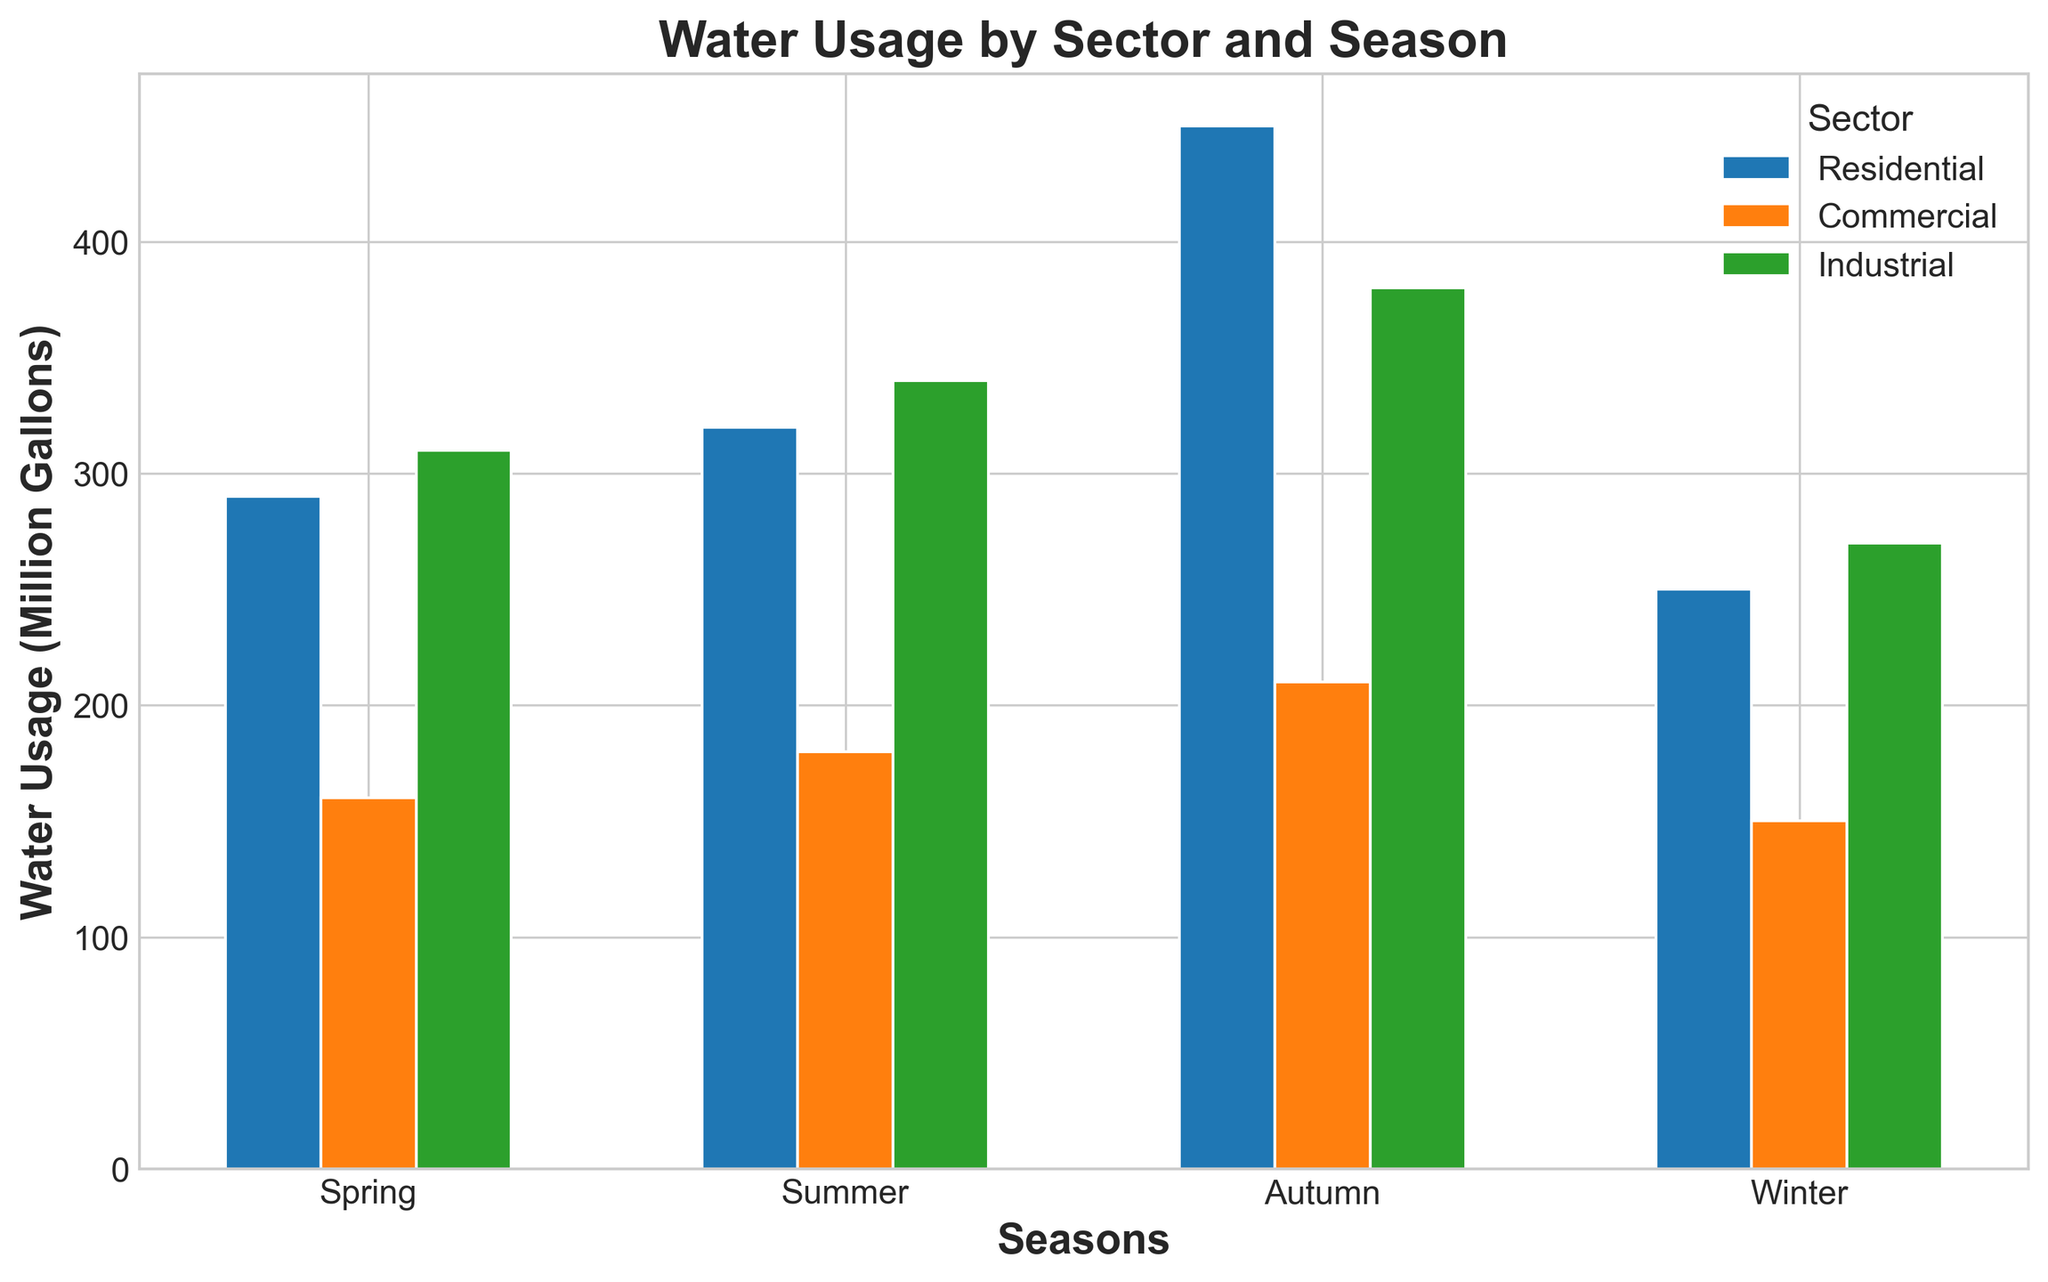What is the season with the lowest water usage for the residential sector? By examining the residential sector's bars across all seasons, the shortest bar represents the lowest water usage. The winter season has the shortest bar.
Answer: Winter Which sector has the highest water usage in summer? Compare the height of all bars in the summer group. The residential sector bar is the tallest in this group.
Answer: Residential Compare the water usage between the residential and industrial sectors in spring. Which one is higher? Compare the heights of the bars for the residential and industrial sectors in the spring. The industrial sector's bar is taller than the residential sector's bar.
Answer: Industrial What is the total water usage for the commercial sector across all seasons? Sum the height of the bars for the commercial sector in spring, summer, autumn, and winter: 180 + 210 + 160 + 150 = 700.
Answer: 700 Million Gallons Which season has the smallest overall water usage considering all three sectors combined? Sum the height of the bars for all sectors in each season:  
Spring: 320 + 180 + 340 = 840  
Summer: 450 + 210 + 380 = 1040  
Autumn: 290 + 160 + 310 = 760  
Winter: 250 + 150 + 270 = 670  
Winter has the smallest combined total.
Answer: Winter Which bar represents the highest water usage overall, and which sector and season does it belong to? Identify the tallest bar in the entire plot. The tallest bar belongs to the residential sector in the summer season.
Answer: Residential in Summer Calculate the difference in water usage between summer and winter for the industrial sector. Subtract the industrial sector bar height in winter from the bar height in summer: 380 - 270 = 110.
Answer: 110 Million Gallons How does the commercial sector's water usage in autumn compare to the residential sector's water usage in the same season? Compare the heights of the commercial and residential sector bars in autumn. The residential sector's bar is taller than the commercial sector's bar.
Answer: Residential has higher usage Describe the visual difference between the bars representing spring and autumn for the commercial sector. Look at the bars of the commercial sector for both seasons. The bar for spring is visibly higher than the bar for autumn.
Answer: Spring bar is higher Between the residential sector's water usage in spring and autumn, which one is higher and by how much? Compare the heights of the residential sector's bars in spring and autumn. Spring's usage is 320 and autumn's usage is 290. The difference is 320 - 290 = 30.
Answer: Spring is higher by 30 Million Gallons 